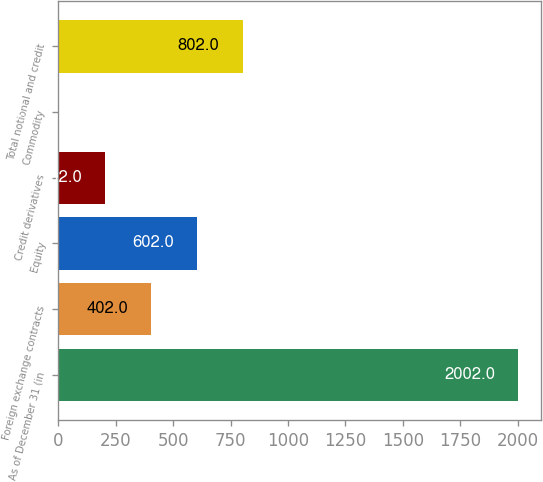Convert chart. <chart><loc_0><loc_0><loc_500><loc_500><bar_chart><fcel>As of December 31 (in<fcel>Foreign exchange contracts<fcel>Equity<fcel>Credit derivatives<fcel>Commodity<fcel>Total notional and credit<nl><fcel>2002<fcel>402<fcel>602<fcel>202<fcel>2<fcel>802<nl></chart> 